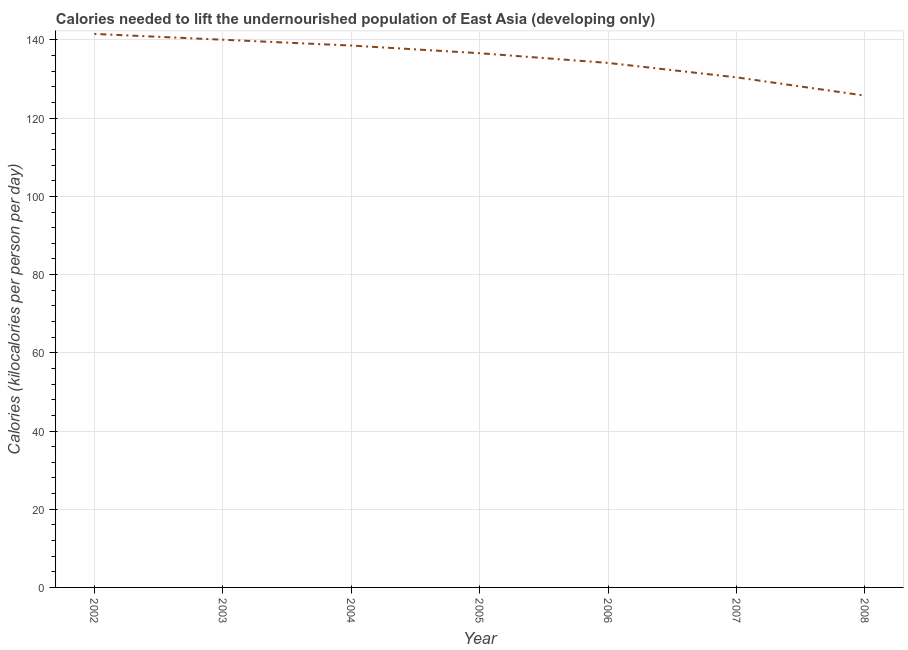What is the depth of food deficit in 2003?
Your response must be concise. 140.06. Across all years, what is the maximum depth of food deficit?
Your answer should be very brief. 141.55. Across all years, what is the minimum depth of food deficit?
Your response must be concise. 125.77. In which year was the depth of food deficit maximum?
Make the answer very short. 2002. What is the sum of the depth of food deficit?
Make the answer very short. 947.14. What is the difference between the depth of food deficit in 2003 and 2008?
Ensure brevity in your answer.  14.3. What is the average depth of food deficit per year?
Offer a very short reply. 135.31. What is the median depth of food deficit?
Provide a succinct answer. 136.62. In how many years, is the depth of food deficit greater than 132 kilocalories?
Your answer should be compact. 5. Do a majority of the years between 2002 and 2007 (inclusive) have depth of food deficit greater than 12 kilocalories?
Offer a terse response. Yes. What is the ratio of the depth of food deficit in 2002 to that in 2003?
Your response must be concise. 1.01. Is the difference between the depth of food deficit in 2006 and 2007 greater than the difference between any two years?
Keep it short and to the point. No. What is the difference between the highest and the second highest depth of food deficit?
Provide a short and direct response. 1.49. Is the sum of the depth of food deficit in 2006 and 2008 greater than the maximum depth of food deficit across all years?
Give a very brief answer. Yes. What is the difference between the highest and the lowest depth of food deficit?
Offer a terse response. 15.79. In how many years, is the depth of food deficit greater than the average depth of food deficit taken over all years?
Keep it short and to the point. 4. How many lines are there?
Ensure brevity in your answer.  1. How many years are there in the graph?
Provide a short and direct response. 7. What is the title of the graph?
Your answer should be compact. Calories needed to lift the undernourished population of East Asia (developing only). What is the label or title of the Y-axis?
Offer a very short reply. Calories (kilocalories per person per day). What is the Calories (kilocalories per person per day) of 2002?
Your answer should be compact. 141.55. What is the Calories (kilocalories per person per day) in 2003?
Provide a short and direct response. 140.06. What is the Calories (kilocalories per person per day) of 2004?
Give a very brief answer. 138.57. What is the Calories (kilocalories per person per day) in 2005?
Ensure brevity in your answer.  136.62. What is the Calories (kilocalories per person per day) in 2006?
Make the answer very short. 134.13. What is the Calories (kilocalories per person per day) of 2007?
Offer a terse response. 130.44. What is the Calories (kilocalories per person per day) of 2008?
Make the answer very short. 125.77. What is the difference between the Calories (kilocalories per person per day) in 2002 and 2003?
Make the answer very short. 1.49. What is the difference between the Calories (kilocalories per person per day) in 2002 and 2004?
Keep it short and to the point. 2.98. What is the difference between the Calories (kilocalories per person per day) in 2002 and 2005?
Your response must be concise. 4.94. What is the difference between the Calories (kilocalories per person per day) in 2002 and 2006?
Provide a short and direct response. 7.42. What is the difference between the Calories (kilocalories per person per day) in 2002 and 2007?
Give a very brief answer. 11.12. What is the difference between the Calories (kilocalories per person per day) in 2002 and 2008?
Make the answer very short. 15.79. What is the difference between the Calories (kilocalories per person per day) in 2003 and 2004?
Your answer should be compact. 1.49. What is the difference between the Calories (kilocalories per person per day) in 2003 and 2005?
Your response must be concise. 3.45. What is the difference between the Calories (kilocalories per person per day) in 2003 and 2006?
Make the answer very short. 5.94. What is the difference between the Calories (kilocalories per person per day) in 2003 and 2007?
Offer a very short reply. 9.63. What is the difference between the Calories (kilocalories per person per day) in 2003 and 2008?
Keep it short and to the point. 14.3. What is the difference between the Calories (kilocalories per person per day) in 2004 and 2005?
Make the answer very short. 1.95. What is the difference between the Calories (kilocalories per person per day) in 2004 and 2006?
Provide a short and direct response. 4.44. What is the difference between the Calories (kilocalories per person per day) in 2004 and 2007?
Your answer should be compact. 8.13. What is the difference between the Calories (kilocalories per person per day) in 2004 and 2008?
Provide a short and direct response. 12.81. What is the difference between the Calories (kilocalories per person per day) in 2005 and 2006?
Provide a short and direct response. 2.49. What is the difference between the Calories (kilocalories per person per day) in 2005 and 2007?
Offer a terse response. 6.18. What is the difference between the Calories (kilocalories per person per day) in 2005 and 2008?
Keep it short and to the point. 10.85. What is the difference between the Calories (kilocalories per person per day) in 2006 and 2007?
Offer a terse response. 3.69. What is the difference between the Calories (kilocalories per person per day) in 2006 and 2008?
Your answer should be compact. 8.36. What is the difference between the Calories (kilocalories per person per day) in 2007 and 2008?
Provide a short and direct response. 4.67. What is the ratio of the Calories (kilocalories per person per day) in 2002 to that in 2005?
Your answer should be very brief. 1.04. What is the ratio of the Calories (kilocalories per person per day) in 2002 to that in 2006?
Your response must be concise. 1.05. What is the ratio of the Calories (kilocalories per person per day) in 2002 to that in 2007?
Make the answer very short. 1.08. What is the ratio of the Calories (kilocalories per person per day) in 2002 to that in 2008?
Offer a very short reply. 1.13. What is the ratio of the Calories (kilocalories per person per day) in 2003 to that in 2005?
Provide a short and direct response. 1.02. What is the ratio of the Calories (kilocalories per person per day) in 2003 to that in 2006?
Offer a terse response. 1.04. What is the ratio of the Calories (kilocalories per person per day) in 2003 to that in 2007?
Provide a short and direct response. 1.07. What is the ratio of the Calories (kilocalories per person per day) in 2003 to that in 2008?
Provide a succinct answer. 1.11. What is the ratio of the Calories (kilocalories per person per day) in 2004 to that in 2006?
Your response must be concise. 1.03. What is the ratio of the Calories (kilocalories per person per day) in 2004 to that in 2007?
Give a very brief answer. 1.06. What is the ratio of the Calories (kilocalories per person per day) in 2004 to that in 2008?
Your answer should be compact. 1.1. What is the ratio of the Calories (kilocalories per person per day) in 2005 to that in 2006?
Your response must be concise. 1.02. What is the ratio of the Calories (kilocalories per person per day) in 2005 to that in 2007?
Your response must be concise. 1.05. What is the ratio of the Calories (kilocalories per person per day) in 2005 to that in 2008?
Provide a succinct answer. 1.09. What is the ratio of the Calories (kilocalories per person per day) in 2006 to that in 2007?
Your answer should be very brief. 1.03. What is the ratio of the Calories (kilocalories per person per day) in 2006 to that in 2008?
Ensure brevity in your answer.  1.07. What is the ratio of the Calories (kilocalories per person per day) in 2007 to that in 2008?
Offer a terse response. 1.04. 